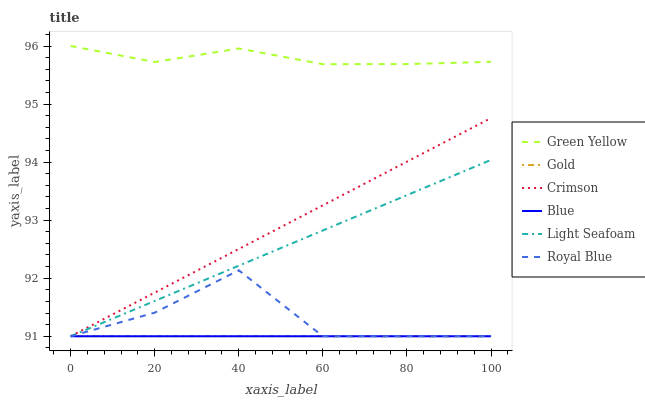Does Blue have the minimum area under the curve?
Answer yes or no. Yes. Does Green Yellow have the maximum area under the curve?
Answer yes or no. Yes. Does Light Seafoam have the minimum area under the curve?
Answer yes or no. No. Does Light Seafoam have the maximum area under the curve?
Answer yes or no. No. Is Blue the smoothest?
Answer yes or no. Yes. Is Royal Blue the roughest?
Answer yes or no. Yes. Is Light Seafoam the smoothest?
Answer yes or no. No. Is Light Seafoam the roughest?
Answer yes or no. No. Does Green Yellow have the lowest value?
Answer yes or no. No. Does Light Seafoam have the highest value?
Answer yes or no. No. Is Gold less than Green Yellow?
Answer yes or no. Yes. Is Green Yellow greater than Royal Blue?
Answer yes or no. Yes. Does Gold intersect Green Yellow?
Answer yes or no. No. 